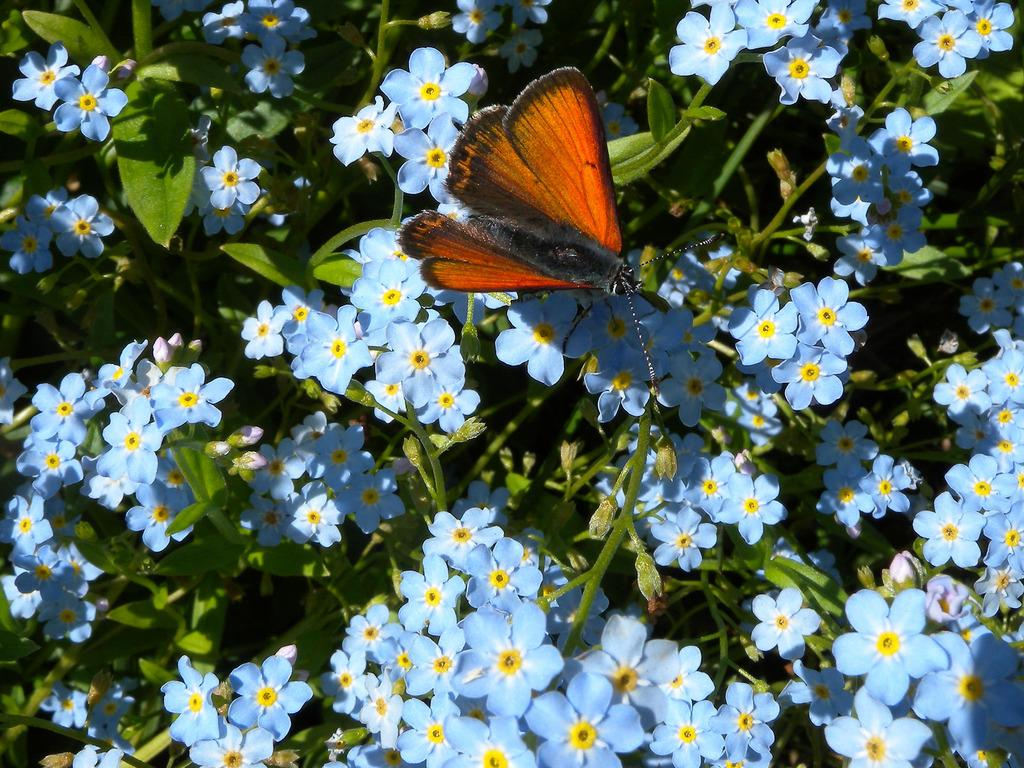What color are the flowers in the image? The flowers in the image are blue. What else can be seen on the stems besides the flowers? There are leaves on the stems in the image. What insect is present on the flowers in the image? There is a butterfly on the flowers in the image. What type of cough medicine is visible on the flowers in the image? There is no cough medicine present in the image; it features blue flowers, leaves, and a butterfly. 